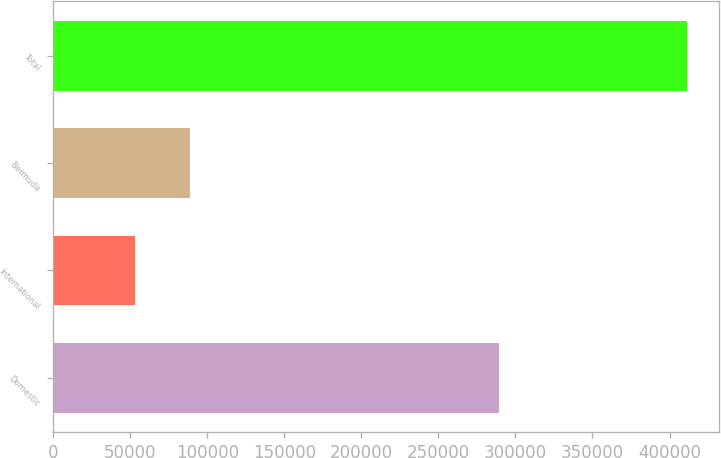<chart> <loc_0><loc_0><loc_500><loc_500><bar_chart><fcel>Domestic<fcel>International<fcel>Bermuda<fcel>Total<nl><fcel>289636<fcel>53186<fcel>89026.1<fcel>411587<nl></chart> 